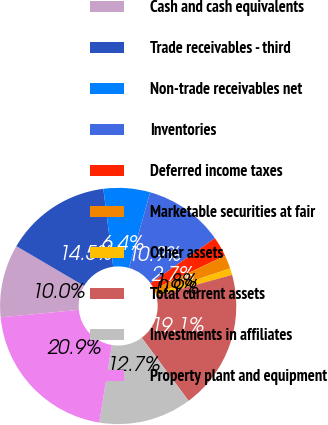Convert chart to OTSL. <chart><loc_0><loc_0><loc_500><loc_500><pie_chart><fcel>Cash and cash equivalents<fcel>Trade receivables - third<fcel>Non-trade receivables net<fcel>Inventories<fcel>Deferred income taxes<fcel>Marketable securities at fair<fcel>Other assets<fcel>Total current assets<fcel>Investments in affiliates<fcel>Property plant and equipment<nl><fcel>10.0%<fcel>14.54%<fcel>6.37%<fcel>10.91%<fcel>2.74%<fcel>1.83%<fcel>0.92%<fcel>19.08%<fcel>12.72%<fcel>20.9%<nl></chart> 